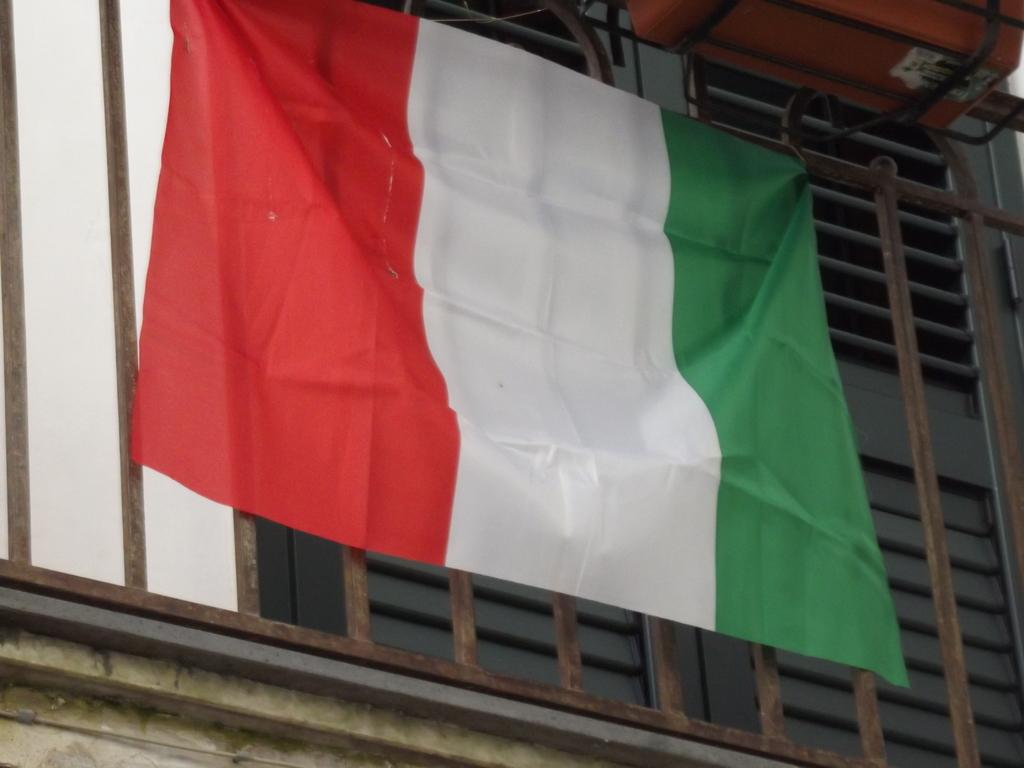What can be seen flying or displayed in the image? There is a flag in the image. What type of cooking equipment is present in the image? There are grills in the image. Who is the creator of the flag in the image? The creator of the flag is not visible or identifiable in the image. What type of health advice can be found in the image? There is no health advice present in the image; it only features a flag and grills. 